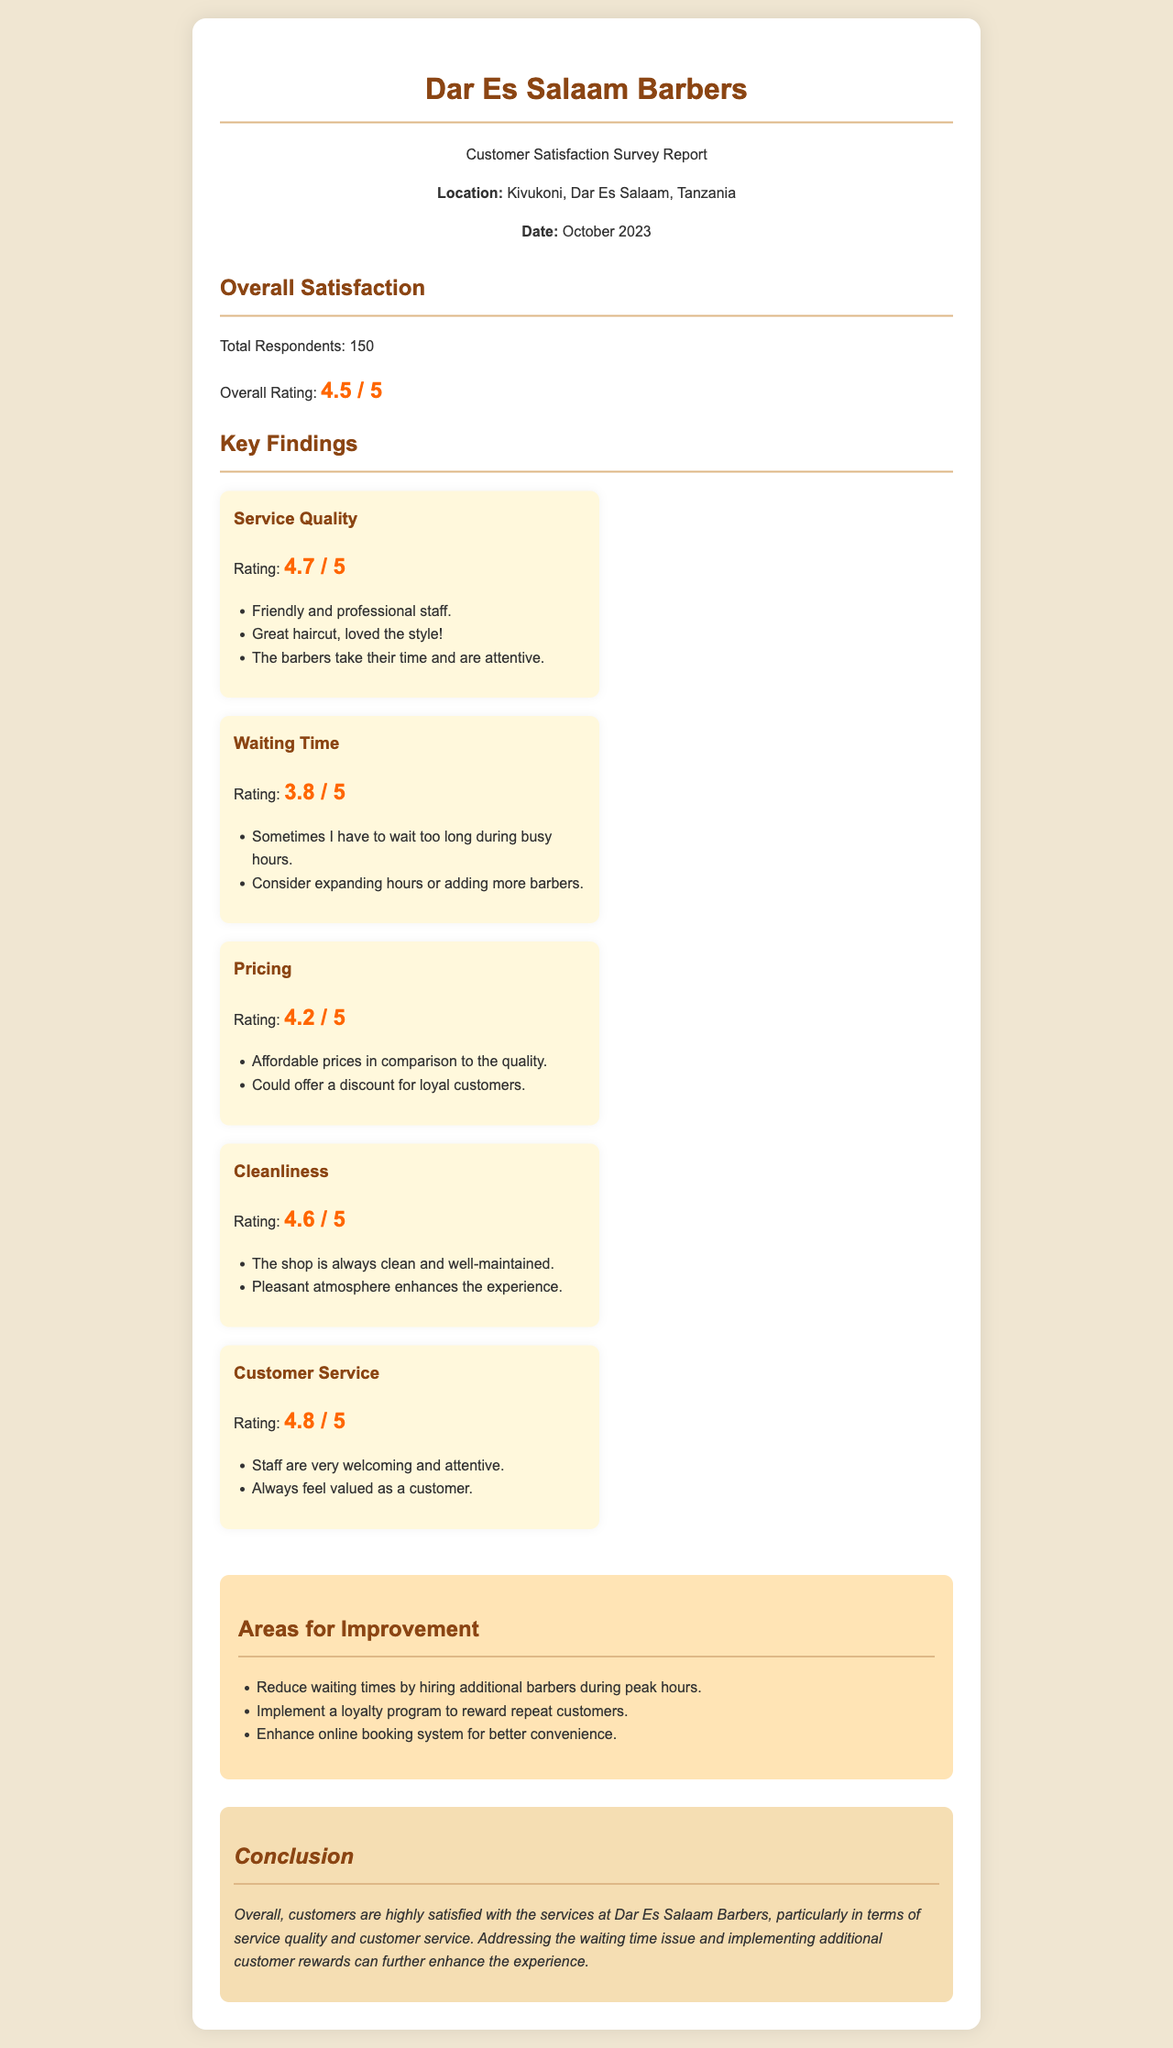What is the total number of respondents? The total number of respondents is explicitly stated in the survey report.
Answer: 150 What is the overall rating of customer satisfaction? The overall rating of customer satisfaction is mentioned in the report summary.
Answer: 4.5 / 5 Which aspect received the highest rating? The ratings for various aspects of the service are compared in the report.
Answer: Customer Service What is suggested to improve waiting times? The document outlines suggestions for reducing waiting times based on customer feedback.
Answer: Hire additional barbers What is the rating for cleanliness? The cleanliness rating is provided as part of the key findings in the report.
Answer: 4.6 / 5 What is one suggested area for improvement in pricing? The report includes recommendations for pricing improvements based on customer feedback.
Answer: Offer a discount for loyal customers What is the rating of service quality? The rating for service quality is specified in the key findings section of the report.
Answer: 4.7 / 5 What location is the barbershop in? The location of the barbershop is mentioned in the header of the report.
Answer: Kivukoni, Dar Es Salaam, Tanzania What rating did the "Waiting Time" receive? The "Waiting Time" rating is included in the report's key findings.
Answer: 3.8 / 5 